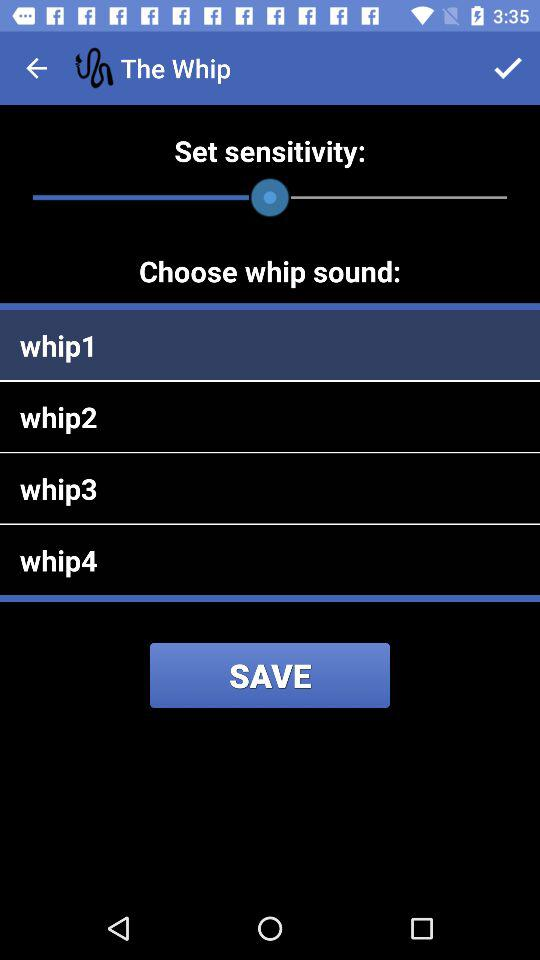Which whip sound has been selected? The sound that has been selected is "whip1". 